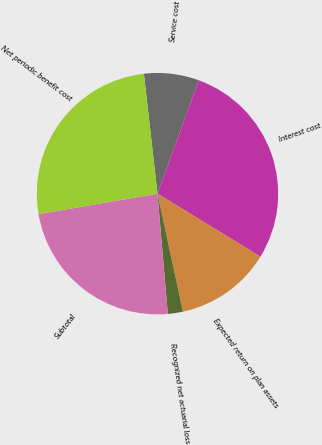Convert chart. <chart><loc_0><loc_0><loc_500><loc_500><pie_chart><fcel>Service cost<fcel>Interest cost<fcel>Expected return on plan assets<fcel>Recognized net actuarial loss<fcel>Subtotal<fcel>Net periodic benefit cost<nl><fcel>7.36%<fcel>28.18%<fcel>12.88%<fcel>2.02%<fcel>23.66%<fcel>25.92%<nl></chart> 